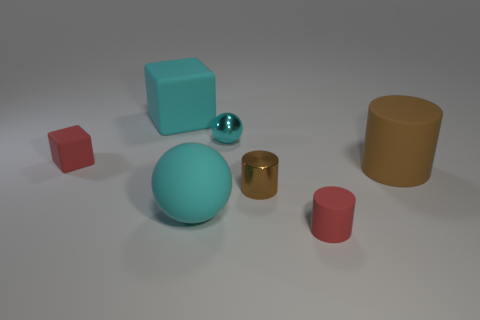Add 2 big cyan matte things. How many objects exist? 9 Subtract all balls. How many objects are left? 5 Subtract 0 purple cylinders. How many objects are left? 7 Subtract all large metal cylinders. Subtract all big matte cubes. How many objects are left? 6 Add 4 small blocks. How many small blocks are left? 5 Add 1 small brown rubber objects. How many small brown rubber objects exist? 1 